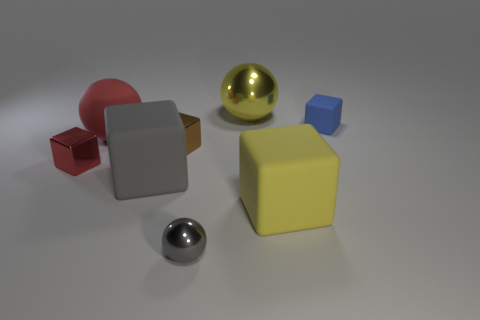Subtract all cyan cubes. Subtract all green cylinders. How many cubes are left? 5 Add 1 tiny spheres. How many objects exist? 9 Subtract all balls. How many objects are left? 5 Add 7 brown metal objects. How many brown metal objects exist? 8 Subtract 1 red blocks. How many objects are left? 7 Subtract all tiny purple matte cylinders. Subtract all tiny blue matte blocks. How many objects are left? 7 Add 5 small red metal objects. How many small red metal objects are left? 6 